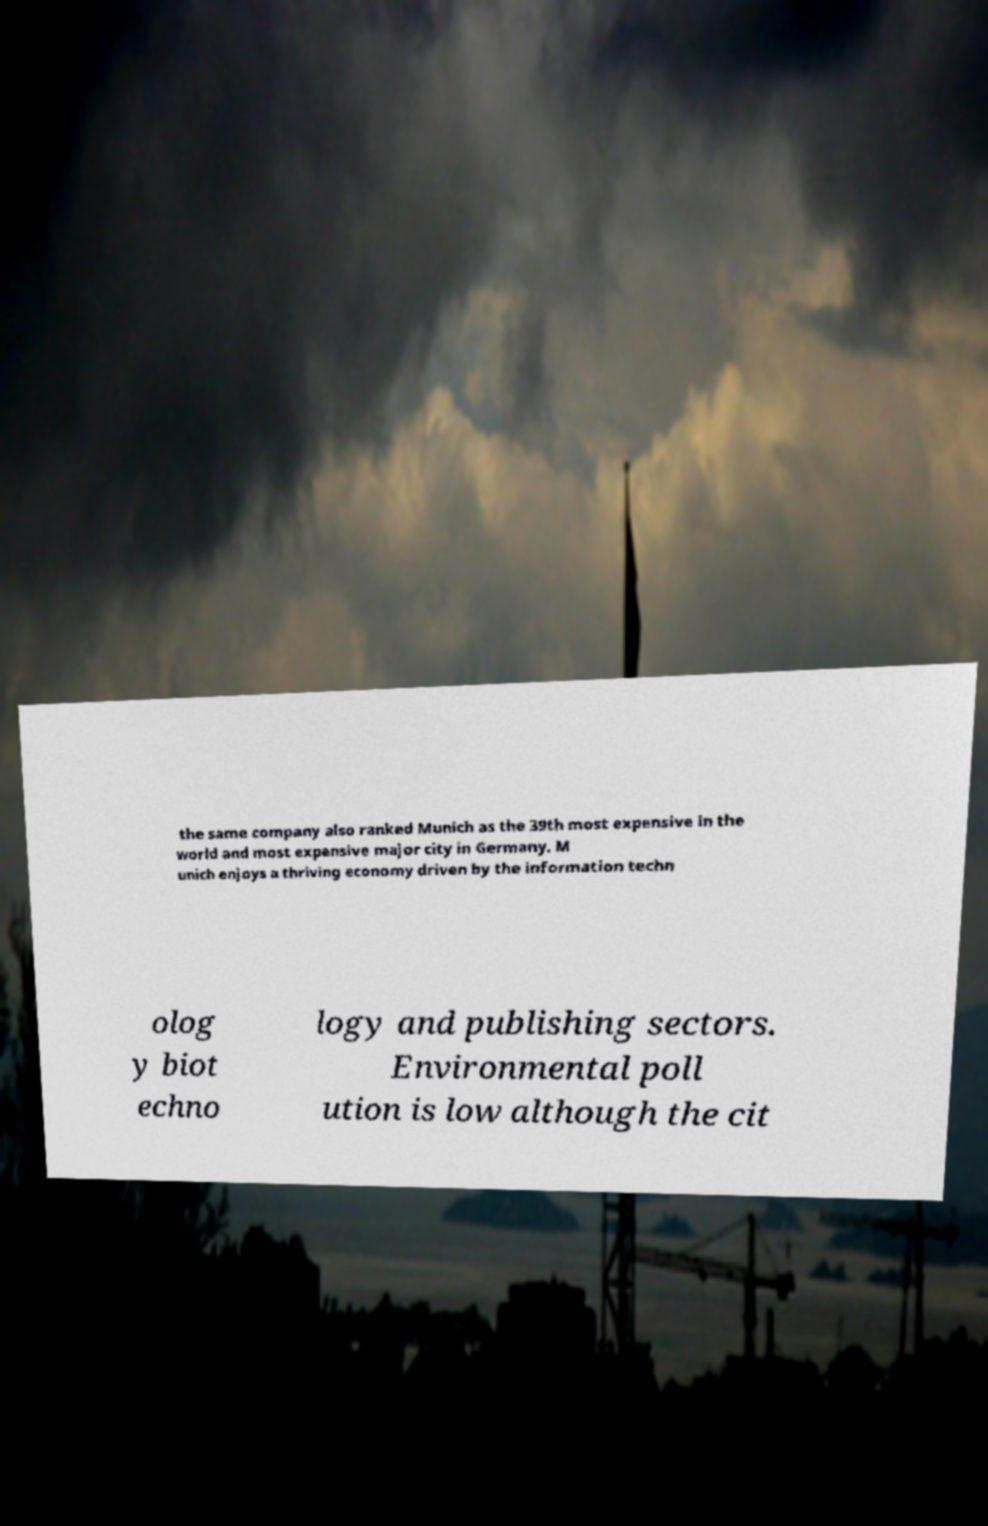What messages or text are displayed in this image? I need them in a readable, typed format. the same company also ranked Munich as the 39th most expensive in the world and most expensive major city in Germany. M unich enjoys a thriving economy driven by the information techn olog y biot echno logy and publishing sectors. Environmental poll ution is low although the cit 